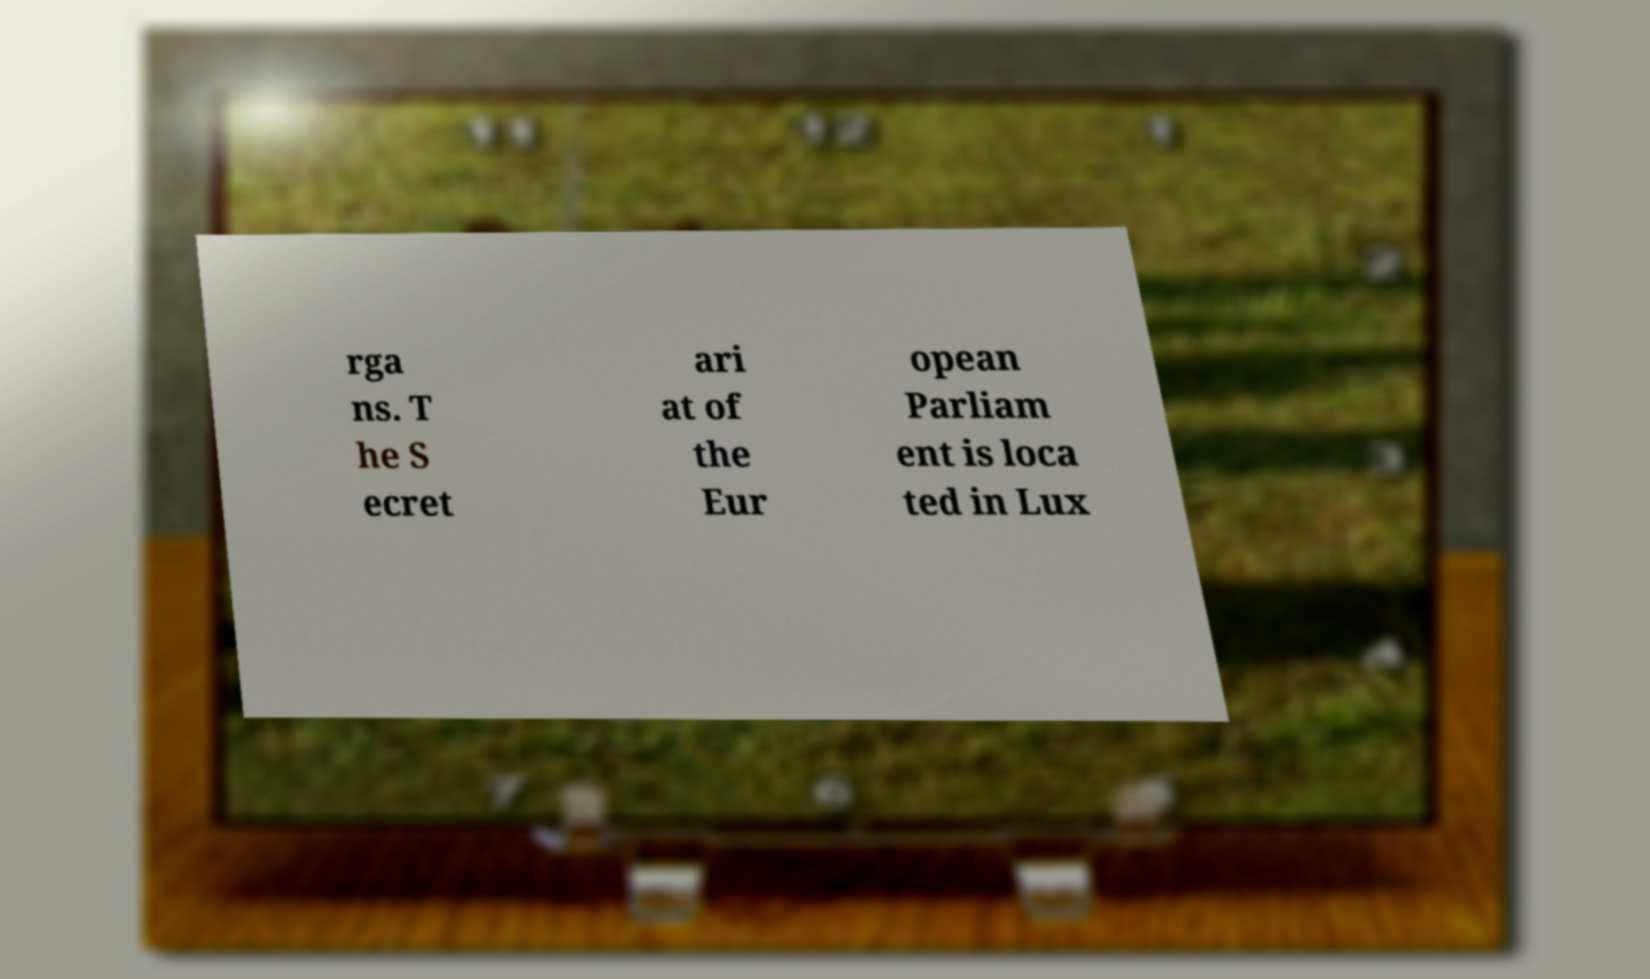Please read and relay the text visible in this image. What does it say? rga ns. T he S ecret ari at of the Eur opean Parliam ent is loca ted in Lux 